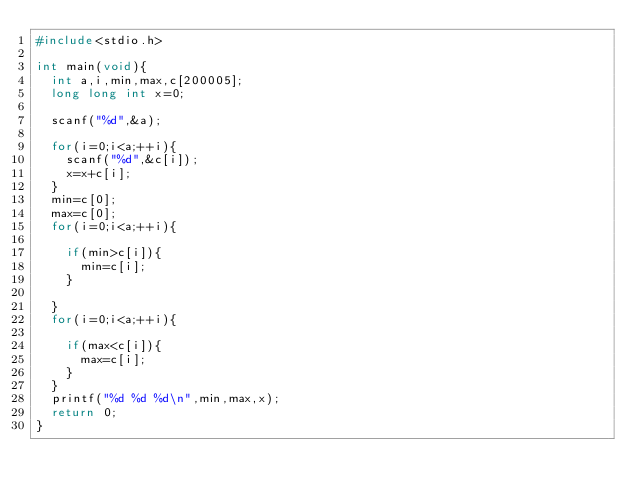Convert code to text. <code><loc_0><loc_0><loc_500><loc_500><_C_>#include<stdio.h>

int main(void){
	int a,i,min,max,c[200005];
	long long int x=0;

	scanf("%d",&a);
	
	for(i=0;i<a;++i){
		scanf("%d",&c[i]);
		x=x+c[i];
	}
	min=c[0];
	max=c[0];
	for(i=0;i<a;++i){

		if(min>c[i]){
			min=c[i];
		}
		
	}
	for(i=0;i<a;++i){

		if(max<c[i]){
			max=c[i];
		}
	}
	printf("%d %d %d\n",min,max,x);
	return 0;
}</code> 